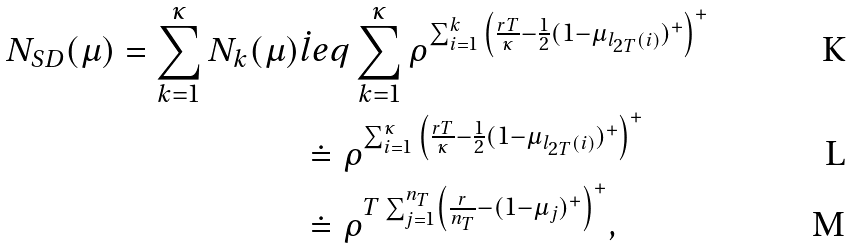Convert formula to latex. <formula><loc_0><loc_0><loc_500><loc_500>N _ { S D } ( \mu ) = \sum _ { k = 1 } ^ { \kappa } N _ { k } ( \mu ) & \dot { l } e q \sum _ { k = 1 } ^ { \kappa } \rho ^ { \sum _ { i = 1 } ^ { k } { \left ( \frac { r T } { \kappa } - \frac { 1 } { 2 } ( 1 - \mu _ { l _ { 2 T } ( i ) } ) ^ { + } \right ) ^ { + } } } \\ & \doteq \rho ^ { \sum _ { i = 1 } ^ { \kappa } { \left ( \frac { r T } { \kappa } - \frac { 1 } { 2 } ( 1 - \mu _ { l _ { 2 T } ( i ) } ) ^ { + } \right ) ^ { + } } } \\ & \doteq \rho ^ { T \sum _ { j = 1 } ^ { n _ { T } } \left ( \frac { r } { n _ { T } } - ( 1 - \mu _ { j } ) ^ { + } \right ) ^ { + } } ,</formula> 